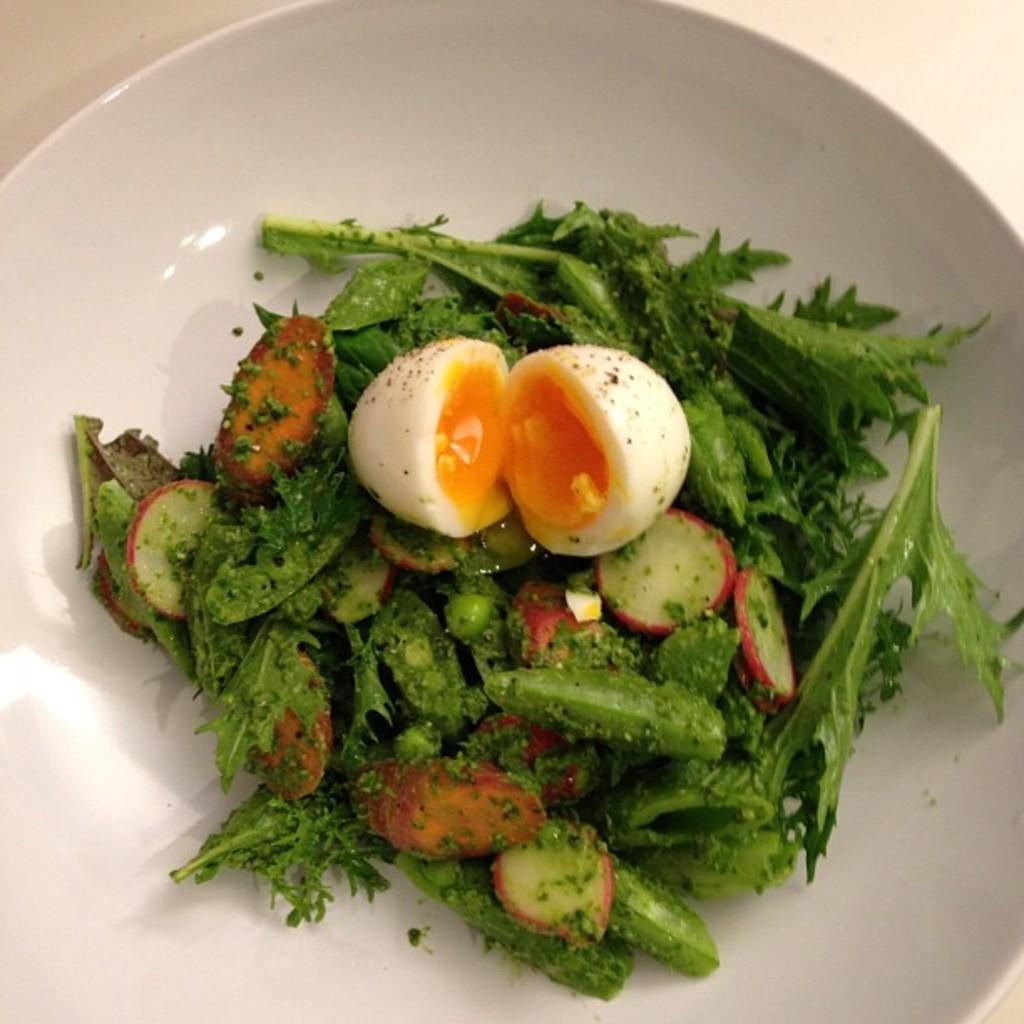What is on the plate in the image? There is a white plate in the image, and on it, there is a food item with green leaves and a boiled egg. Can you describe the food item with green leaves? Unfortunately, the specific type of food item with green leaves cannot be determined from the image. Are there any other items on the plate besides the food item with green leaves and the boiled egg? Yes, there are other unspecified items on the plate. How many grapes are on the elbow of the person in the image? There is no person or grapes present in the image. 